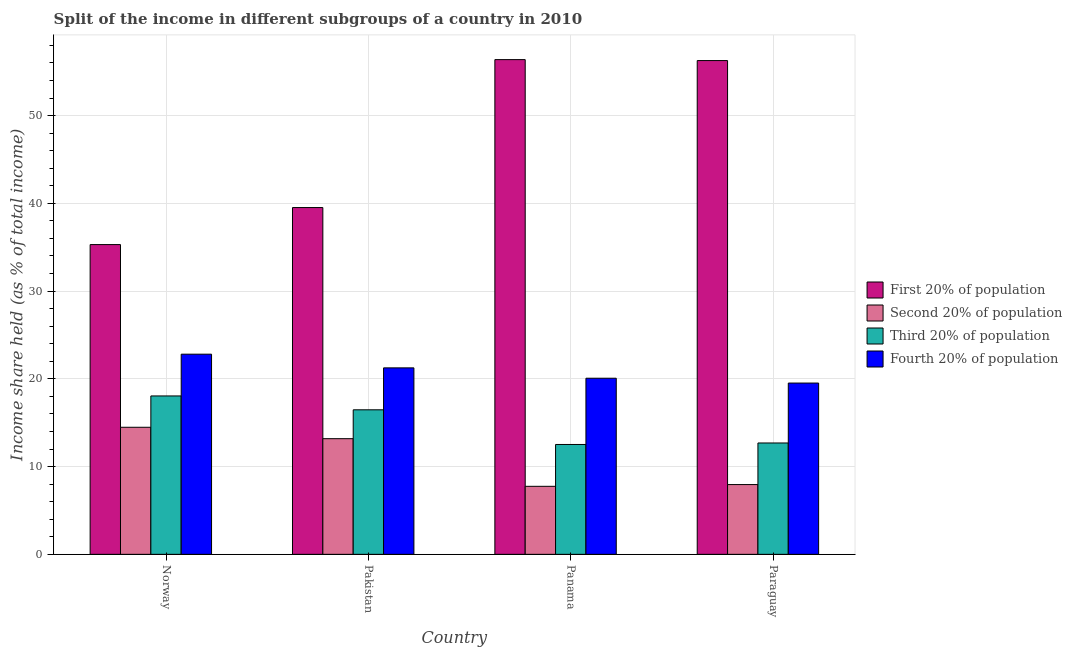What is the label of the 4th group of bars from the left?
Offer a terse response. Paraguay. What is the share of the income held by third 20% of the population in Norway?
Your response must be concise. 18.05. Across all countries, what is the maximum share of the income held by third 20% of the population?
Your answer should be compact. 18.05. Across all countries, what is the minimum share of the income held by fourth 20% of the population?
Offer a very short reply. 19.52. In which country was the share of the income held by second 20% of the population minimum?
Make the answer very short. Panama. What is the total share of the income held by second 20% of the population in the graph?
Provide a succinct answer. 43.36. What is the difference between the share of the income held by second 20% of the population in Pakistan and that in Panama?
Ensure brevity in your answer.  5.43. What is the difference between the share of the income held by first 20% of the population in Paraguay and the share of the income held by third 20% of the population in Panama?
Your answer should be compact. 43.75. What is the average share of the income held by first 20% of the population per country?
Offer a very short reply. 46.87. What is the difference between the share of the income held by fourth 20% of the population and share of the income held by third 20% of the population in Pakistan?
Offer a very short reply. 4.78. In how many countries, is the share of the income held by third 20% of the population greater than 10 %?
Provide a short and direct response. 4. What is the ratio of the share of the income held by fourth 20% of the population in Pakistan to that in Paraguay?
Give a very brief answer. 1.09. What is the difference between the highest and the second highest share of the income held by fourth 20% of the population?
Provide a short and direct response. 1.56. What is the difference between the highest and the lowest share of the income held by second 20% of the population?
Provide a short and direct response. 6.73. Is the sum of the share of the income held by first 20% of the population in Norway and Paraguay greater than the maximum share of the income held by third 20% of the population across all countries?
Your answer should be compact. Yes. Is it the case that in every country, the sum of the share of the income held by first 20% of the population and share of the income held by third 20% of the population is greater than the sum of share of the income held by second 20% of the population and share of the income held by fourth 20% of the population?
Offer a very short reply. No. What does the 1st bar from the left in Panama represents?
Give a very brief answer. First 20% of population. What does the 4th bar from the right in Panama represents?
Give a very brief answer. First 20% of population. Are all the bars in the graph horizontal?
Make the answer very short. No. Are the values on the major ticks of Y-axis written in scientific E-notation?
Make the answer very short. No. Where does the legend appear in the graph?
Keep it short and to the point. Center right. How are the legend labels stacked?
Your answer should be very brief. Vertical. What is the title of the graph?
Your response must be concise. Split of the income in different subgroups of a country in 2010. Does "Quality of logistic services" appear as one of the legend labels in the graph?
Provide a short and direct response. No. What is the label or title of the Y-axis?
Make the answer very short. Income share held (as % of total income). What is the Income share held (as % of total income) of First 20% of population in Norway?
Make the answer very short. 35.3. What is the Income share held (as % of total income) in Second 20% of population in Norway?
Give a very brief answer. 14.48. What is the Income share held (as % of total income) in Third 20% of population in Norway?
Provide a succinct answer. 18.05. What is the Income share held (as % of total income) in Fourth 20% of population in Norway?
Ensure brevity in your answer.  22.81. What is the Income share held (as % of total income) in First 20% of population in Pakistan?
Ensure brevity in your answer.  39.52. What is the Income share held (as % of total income) in Second 20% of population in Pakistan?
Provide a short and direct response. 13.18. What is the Income share held (as % of total income) in Third 20% of population in Pakistan?
Ensure brevity in your answer.  16.47. What is the Income share held (as % of total income) of Fourth 20% of population in Pakistan?
Your answer should be very brief. 21.25. What is the Income share held (as % of total income) of First 20% of population in Panama?
Keep it short and to the point. 56.38. What is the Income share held (as % of total income) of Second 20% of population in Panama?
Make the answer very short. 7.75. What is the Income share held (as % of total income) of Third 20% of population in Panama?
Offer a terse response. 12.52. What is the Income share held (as % of total income) in Fourth 20% of population in Panama?
Your answer should be very brief. 20.07. What is the Income share held (as % of total income) in First 20% of population in Paraguay?
Keep it short and to the point. 56.27. What is the Income share held (as % of total income) in Second 20% of population in Paraguay?
Your answer should be very brief. 7.95. What is the Income share held (as % of total income) of Third 20% of population in Paraguay?
Provide a succinct answer. 12.69. What is the Income share held (as % of total income) of Fourth 20% of population in Paraguay?
Your answer should be very brief. 19.52. Across all countries, what is the maximum Income share held (as % of total income) in First 20% of population?
Your answer should be very brief. 56.38. Across all countries, what is the maximum Income share held (as % of total income) in Second 20% of population?
Provide a succinct answer. 14.48. Across all countries, what is the maximum Income share held (as % of total income) in Third 20% of population?
Your answer should be very brief. 18.05. Across all countries, what is the maximum Income share held (as % of total income) in Fourth 20% of population?
Your response must be concise. 22.81. Across all countries, what is the minimum Income share held (as % of total income) of First 20% of population?
Offer a very short reply. 35.3. Across all countries, what is the minimum Income share held (as % of total income) in Second 20% of population?
Provide a succinct answer. 7.75. Across all countries, what is the minimum Income share held (as % of total income) of Third 20% of population?
Offer a terse response. 12.52. Across all countries, what is the minimum Income share held (as % of total income) of Fourth 20% of population?
Keep it short and to the point. 19.52. What is the total Income share held (as % of total income) of First 20% of population in the graph?
Offer a very short reply. 187.47. What is the total Income share held (as % of total income) of Second 20% of population in the graph?
Your response must be concise. 43.36. What is the total Income share held (as % of total income) of Third 20% of population in the graph?
Ensure brevity in your answer.  59.73. What is the total Income share held (as % of total income) in Fourth 20% of population in the graph?
Your response must be concise. 83.65. What is the difference between the Income share held (as % of total income) of First 20% of population in Norway and that in Pakistan?
Your answer should be very brief. -4.22. What is the difference between the Income share held (as % of total income) in Third 20% of population in Norway and that in Pakistan?
Provide a short and direct response. 1.58. What is the difference between the Income share held (as % of total income) in Fourth 20% of population in Norway and that in Pakistan?
Offer a very short reply. 1.56. What is the difference between the Income share held (as % of total income) of First 20% of population in Norway and that in Panama?
Your answer should be compact. -21.08. What is the difference between the Income share held (as % of total income) of Second 20% of population in Norway and that in Panama?
Provide a succinct answer. 6.73. What is the difference between the Income share held (as % of total income) of Third 20% of population in Norway and that in Panama?
Your response must be concise. 5.53. What is the difference between the Income share held (as % of total income) in Fourth 20% of population in Norway and that in Panama?
Offer a very short reply. 2.74. What is the difference between the Income share held (as % of total income) of First 20% of population in Norway and that in Paraguay?
Your answer should be compact. -20.97. What is the difference between the Income share held (as % of total income) in Second 20% of population in Norway and that in Paraguay?
Your answer should be very brief. 6.53. What is the difference between the Income share held (as % of total income) of Third 20% of population in Norway and that in Paraguay?
Provide a succinct answer. 5.36. What is the difference between the Income share held (as % of total income) of Fourth 20% of population in Norway and that in Paraguay?
Ensure brevity in your answer.  3.29. What is the difference between the Income share held (as % of total income) in First 20% of population in Pakistan and that in Panama?
Offer a very short reply. -16.86. What is the difference between the Income share held (as % of total income) of Second 20% of population in Pakistan and that in Panama?
Your response must be concise. 5.43. What is the difference between the Income share held (as % of total income) of Third 20% of population in Pakistan and that in Panama?
Provide a short and direct response. 3.95. What is the difference between the Income share held (as % of total income) in Fourth 20% of population in Pakistan and that in Panama?
Your answer should be compact. 1.18. What is the difference between the Income share held (as % of total income) of First 20% of population in Pakistan and that in Paraguay?
Your answer should be compact. -16.75. What is the difference between the Income share held (as % of total income) in Second 20% of population in Pakistan and that in Paraguay?
Keep it short and to the point. 5.23. What is the difference between the Income share held (as % of total income) in Third 20% of population in Pakistan and that in Paraguay?
Your response must be concise. 3.78. What is the difference between the Income share held (as % of total income) in Fourth 20% of population in Pakistan and that in Paraguay?
Ensure brevity in your answer.  1.73. What is the difference between the Income share held (as % of total income) of First 20% of population in Panama and that in Paraguay?
Make the answer very short. 0.11. What is the difference between the Income share held (as % of total income) in Third 20% of population in Panama and that in Paraguay?
Your response must be concise. -0.17. What is the difference between the Income share held (as % of total income) of Fourth 20% of population in Panama and that in Paraguay?
Your answer should be very brief. 0.55. What is the difference between the Income share held (as % of total income) of First 20% of population in Norway and the Income share held (as % of total income) of Second 20% of population in Pakistan?
Make the answer very short. 22.12. What is the difference between the Income share held (as % of total income) of First 20% of population in Norway and the Income share held (as % of total income) of Third 20% of population in Pakistan?
Give a very brief answer. 18.83. What is the difference between the Income share held (as % of total income) of First 20% of population in Norway and the Income share held (as % of total income) of Fourth 20% of population in Pakistan?
Give a very brief answer. 14.05. What is the difference between the Income share held (as % of total income) in Second 20% of population in Norway and the Income share held (as % of total income) in Third 20% of population in Pakistan?
Ensure brevity in your answer.  -1.99. What is the difference between the Income share held (as % of total income) in Second 20% of population in Norway and the Income share held (as % of total income) in Fourth 20% of population in Pakistan?
Your answer should be compact. -6.77. What is the difference between the Income share held (as % of total income) of First 20% of population in Norway and the Income share held (as % of total income) of Second 20% of population in Panama?
Provide a short and direct response. 27.55. What is the difference between the Income share held (as % of total income) in First 20% of population in Norway and the Income share held (as % of total income) in Third 20% of population in Panama?
Make the answer very short. 22.78. What is the difference between the Income share held (as % of total income) in First 20% of population in Norway and the Income share held (as % of total income) in Fourth 20% of population in Panama?
Your answer should be very brief. 15.23. What is the difference between the Income share held (as % of total income) in Second 20% of population in Norway and the Income share held (as % of total income) in Third 20% of population in Panama?
Your answer should be very brief. 1.96. What is the difference between the Income share held (as % of total income) in Second 20% of population in Norway and the Income share held (as % of total income) in Fourth 20% of population in Panama?
Give a very brief answer. -5.59. What is the difference between the Income share held (as % of total income) in Third 20% of population in Norway and the Income share held (as % of total income) in Fourth 20% of population in Panama?
Offer a very short reply. -2.02. What is the difference between the Income share held (as % of total income) of First 20% of population in Norway and the Income share held (as % of total income) of Second 20% of population in Paraguay?
Your answer should be very brief. 27.35. What is the difference between the Income share held (as % of total income) of First 20% of population in Norway and the Income share held (as % of total income) of Third 20% of population in Paraguay?
Offer a very short reply. 22.61. What is the difference between the Income share held (as % of total income) of First 20% of population in Norway and the Income share held (as % of total income) of Fourth 20% of population in Paraguay?
Give a very brief answer. 15.78. What is the difference between the Income share held (as % of total income) in Second 20% of population in Norway and the Income share held (as % of total income) in Third 20% of population in Paraguay?
Your response must be concise. 1.79. What is the difference between the Income share held (as % of total income) in Second 20% of population in Norway and the Income share held (as % of total income) in Fourth 20% of population in Paraguay?
Give a very brief answer. -5.04. What is the difference between the Income share held (as % of total income) in Third 20% of population in Norway and the Income share held (as % of total income) in Fourth 20% of population in Paraguay?
Offer a terse response. -1.47. What is the difference between the Income share held (as % of total income) in First 20% of population in Pakistan and the Income share held (as % of total income) in Second 20% of population in Panama?
Your response must be concise. 31.77. What is the difference between the Income share held (as % of total income) of First 20% of population in Pakistan and the Income share held (as % of total income) of Third 20% of population in Panama?
Offer a terse response. 27. What is the difference between the Income share held (as % of total income) in First 20% of population in Pakistan and the Income share held (as % of total income) in Fourth 20% of population in Panama?
Your response must be concise. 19.45. What is the difference between the Income share held (as % of total income) in Second 20% of population in Pakistan and the Income share held (as % of total income) in Third 20% of population in Panama?
Keep it short and to the point. 0.66. What is the difference between the Income share held (as % of total income) in Second 20% of population in Pakistan and the Income share held (as % of total income) in Fourth 20% of population in Panama?
Ensure brevity in your answer.  -6.89. What is the difference between the Income share held (as % of total income) of First 20% of population in Pakistan and the Income share held (as % of total income) of Second 20% of population in Paraguay?
Offer a very short reply. 31.57. What is the difference between the Income share held (as % of total income) of First 20% of population in Pakistan and the Income share held (as % of total income) of Third 20% of population in Paraguay?
Offer a very short reply. 26.83. What is the difference between the Income share held (as % of total income) of First 20% of population in Pakistan and the Income share held (as % of total income) of Fourth 20% of population in Paraguay?
Offer a terse response. 20. What is the difference between the Income share held (as % of total income) of Second 20% of population in Pakistan and the Income share held (as % of total income) of Third 20% of population in Paraguay?
Give a very brief answer. 0.49. What is the difference between the Income share held (as % of total income) in Second 20% of population in Pakistan and the Income share held (as % of total income) in Fourth 20% of population in Paraguay?
Your answer should be very brief. -6.34. What is the difference between the Income share held (as % of total income) of Third 20% of population in Pakistan and the Income share held (as % of total income) of Fourth 20% of population in Paraguay?
Keep it short and to the point. -3.05. What is the difference between the Income share held (as % of total income) of First 20% of population in Panama and the Income share held (as % of total income) of Second 20% of population in Paraguay?
Your answer should be very brief. 48.43. What is the difference between the Income share held (as % of total income) of First 20% of population in Panama and the Income share held (as % of total income) of Third 20% of population in Paraguay?
Provide a short and direct response. 43.69. What is the difference between the Income share held (as % of total income) of First 20% of population in Panama and the Income share held (as % of total income) of Fourth 20% of population in Paraguay?
Ensure brevity in your answer.  36.86. What is the difference between the Income share held (as % of total income) of Second 20% of population in Panama and the Income share held (as % of total income) of Third 20% of population in Paraguay?
Your answer should be compact. -4.94. What is the difference between the Income share held (as % of total income) of Second 20% of population in Panama and the Income share held (as % of total income) of Fourth 20% of population in Paraguay?
Give a very brief answer. -11.77. What is the average Income share held (as % of total income) in First 20% of population per country?
Your answer should be compact. 46.87. What is the average Income share held (as % of total income) of Second 20% of population per country?
Make the answer very short. 10.84. What is the average Income share held (as % of total income) of Third 20% of population per country?
Keep it short and to the point. 14.93. What is the average Income share held (as % of total income) of Fourth 20% of population per country?
Ensure brevity in your answer.  20.91. What is the difference between the Income share held (as % of total income) in First 20% of population and Income share held (as % of total income) in Second 20% of population in Norway?
Make the answer very short. 20.82. What is the difference between the Income share held (as % of total income) of First 20% of population and Income share held (as % of total income) of Third 20% of population in Norway?
Your response must be concise. 17.25. What is the difference between the Income share held (as % of total income) of First 20% of population and Income share held (as % of total income) of Fourth 20% of population in Norway?
Provide a short and direct response. 12.49. What is the difference between the Income share held (as % of total income) of Second 20% of population and Income share held (as % of total income) of Third 20% of population in Norway?
Your response must be concise. -3.57. What is the difference between the Income share held (as % of total income) in Second 20% of population and Income share held (as % of total income) in Fourth 20% of population in Norway?
Make the answer very short. -8.33. What is the difference between the Income share held (as % of total income) of Third 20% of population and Income share held (as % of total income) of Fourth 20% of population in Norway?
Ensure brevity in your answer.  -4.76. What is the difference between the Income share held (as % of total income) in First 20% of population and Income share held (as % of total income) in Second 20% of population in Pakistan?
Offer a terse response. 26.34. What is the difference between the Income share held (as % of total income) in First 20% of population and Income share held (as % of total income) in Third 20% of population in Pakistan?
Keep it short and to the point. 23.05. What is the difference between the Income share held (as % of total income) of First 20% of population and Income share held (as % of total income) of Fourth 20% of population in Pakistan?
Give a very brief answer. 18.27. What is the difference between the Income share held (as % of total income) of Second 20% of population and Income share held (as % of total income) of Third 20% of population in Pakistan?
Ensure brevity in your answer.  -3.29. What is the difference between the Income share held (as % of total income) in Second 20% of population and Income share held (as % of total income) in Fourth 20% of population in Pakistan?
Keep it short and to the point. -8.07. What is the difference between the Income share held (as % of total income) in Third 20% of population and Income share held (as % of total income) in Fourth 20% of population in Pakistan?
Ensure brevity in your answer.  -4.78. What is the difference between the Income share held (as % of total income) of First 20% of population and Income share held (as % of total income) of Second 20% of population in Panama?
Provide a succinct answer. 48.63. What is the difference between the Income share held (as % of total income) of First 20% of population and Income share held (as % of total income) of Third 20% of population in Panama?
Provide a succinct answer. 43.86. What is the difference between the Income share held (as % of total income) in First 20% of population and Income share held (as % of total income) in Fourth 20% of population in Panama?
Provide a succinct answer. 36.31. What is the difference between the Income share held (as % of total income) in Second 20% of population and Income share held (as % of total income) in Third 20% of population in Panama?
Offer a terse response. -4.77. What is the difference between the Income share held (as % of total income) in Second 20% of population and Income share held (as % of total income) in Fourth 20% of population in Panama?
Your response must be concise. -12.32. What is the difference between the Income share held (as % of total income) of Third 20% of population and Income share held (as % of total income) of Fourth 20% of population in Panama?
Offer a terse response. -7.55. What is the difference between the Income share held (as % of total income) of First 20% of population and Income share held (as % of total income) of Second 20% of population in Paraguay?
Ensure brevity in your answer.  48.32. What is the difference between the Income share held (as % of total income) of First 20% of population and Income share held (as % of total income) of Third 20% of population in Paraguay?
Provide a succinct answer. 43.58. What is the difference between the Income share held (as % of total income) of First 20% of population and Income share held (as % of total income) of Fourth 20% of population in Paraguay?
Provide a short and direct response. 36.75. What is the difference between the Income share held (as % of total income) of Second 20% of population and Income share held (as % of total income) of Third 20% of population in Paraguay?
Offer a very short reply. -4.74. What is the difference between the Income share held (as % of total income) of Second 20% of population and Income share held (as % of total income) of Fourth 20% of population in Paraguay?
Offer a terse response. -11.57. What is the difference between the Income share held (as % of total income) in Third 20% of population and Income share held (as % of total income) in Fourth 20% of population in Paraguay?
Your response must be concise. -6.83. What is the ratio of the Income share held (as % of total income) in First 20% of population in Norway to that in Pakistan?
Ensure brevity in your answer.  0.89. What is the ratio of the Income share held (as % of total income) of Second 20% of population in Norway to that in Pakistan?
Offer a very short reply. 1.1. What is the ratio of the Income share held (as % of total income) of Third 20% of population in Norway to that in Pakistan?
Offer a terse response. 1.1. What is the ratio of the Income share held (as % of total income) of Fourth 20% of population in Norway to that in Pakistan?
Your response must be concise. 1.07. What is the ratio of the Income share held (as % of total income) in First 20% of population in Norway to that in Panama?
Offer a terse response. 0.63. What is the ratio of the Income share held (as % of total income) in Second 20% of population in Norway to that in Panama?
Your answer should be compact. 1.87. What is the ratio of the Income share held (as % of total income) of Third 20% of population in Norway to that in Panama?
Your answer should be very brief. 1.44. What is the ratio of the Income share held (as % of total income) of Fourth 20% of population in Norway to that in Panama?
Your answer should be very brief. 1.14. What is the ratio of the Income share held (as % of total income) in First 20% of population in Norway to that in Paraguay?
Provide a succinct answer. 0.63. What is the ratio of the Income share held (as % of total income) in Second 20% of population in Norway to that in Paraguay?
Make the answer very short. 1.82. What is the ratio of the Income share held (as % of total income) in Third 20% of population in Norway to that in Paraguay?
Offer a very short reply. 1.42. What is the ratio of the Income share held (as % of total income) in Fourth 20% of population in Norway to that in Paraguay?
Keep it short and to the point. 1.17. What is the ratio of the Income share held (as % of total income) of First 20% of population in Pakistan to that in Panama?
Ensure brevity in your answer.  0.7. What is the ratio of the Income share held (as % of total income) in Second 20% of population in Pakistan to that in Panama?
Give a very brief answer. 1.7. What is the ratio of the Income share held (as % of total income) of Third 20% of population in Pakistan to that in Panama?
Your answer should be very brief. 1.32. What is the ratio of the Income share held (as % of total income) in Fourth 20% of population in Pakistan to that in Panama?
Ensure brevity in your answer.  1.06. What is the ratio of the Income share held (as % of total income) of First 20% of population in Pakistan to that in Paraguay?
Provide a short and direct response. 0.7. What is the ratio of the Income share held (as % of total income) in Second 20% of population in Pakistan to that in Paraguay?
Keep it short and to the point. 1.66. What is the ratio of the Income share held (as % of total income) of Third 20% of population in Pakistan to that in Paraguay?
Your answer should be very brief. 1.3. What is the ratio of the Income share held (as % of total income) of Fourth 20% of population in Pakistan to that in Paraguay?
Offer a terse response. 1.09. What is the ratio of the Income share held (as % of total income) in First 20% of population in Panama to that in Paraguay?
Keep it short and to the point. 1. What is the ratio of the Income share held (as % of total income) of Second 20% of population in Panama to that in Paraguay?
Your answer should be compact. 0.97. What is the ratio of the Income share held (as % of total income) of Third 20% of population in Panama to that in Paraguay?
Offer a terse response. 0.99. What is the ratio of the Income share held (as % of total income) of Fourth 20% of population in Panama to that in Paraguay?
Make the answer very short. 1.03. What is the difference between the highest and the second highest Income share held (as % of total income) of First 20% of population?
Provide a succinct answer. 0.11. What is the difference between the highest and the second highest Income share held (as % of total income) in Third 20% of population?
Ensure brevity in your answer.  1.58. What is the difference between the highest and the second highest Income share held (as % of total income) in Fourth 20% of population?
Provide a succinct answer. 1.56. What is the difference between the highest and the lowest Income share held (as % of total income) in First 20% of population?
Your answer should be compact. 21.08. What is the difference between the highest and the lowest Income share held (as % of total income) of Second 20% of population?
Your answer should be very brief. 6.73. What is the difference between the highest and the lowest Income share held (as % of total income) in Third 20% of population?
Offer a very short reply. 5.53. What is the difference between the highest and the lowest Income share held (as % of total income) of Fourth 20% of population?
Your response must be concise. 3.29. 